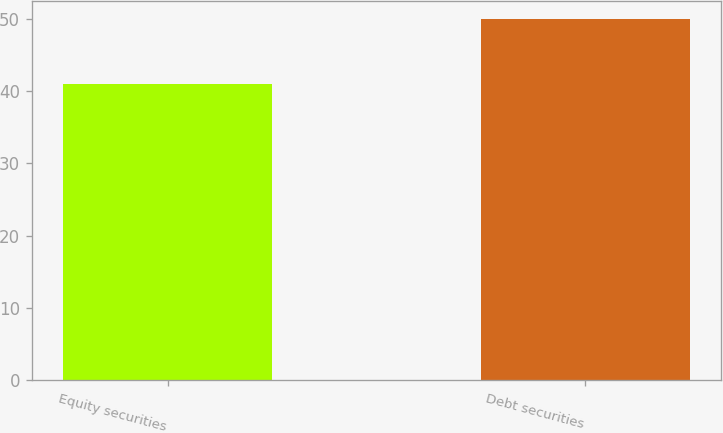Convert chart. <chart><loc_0><loc_0><loc_500><loc_500><bar_chart><fcel>Equity securities<fcel>Debt securities<nl><fcel>41<fcel>50<nl></chart> 